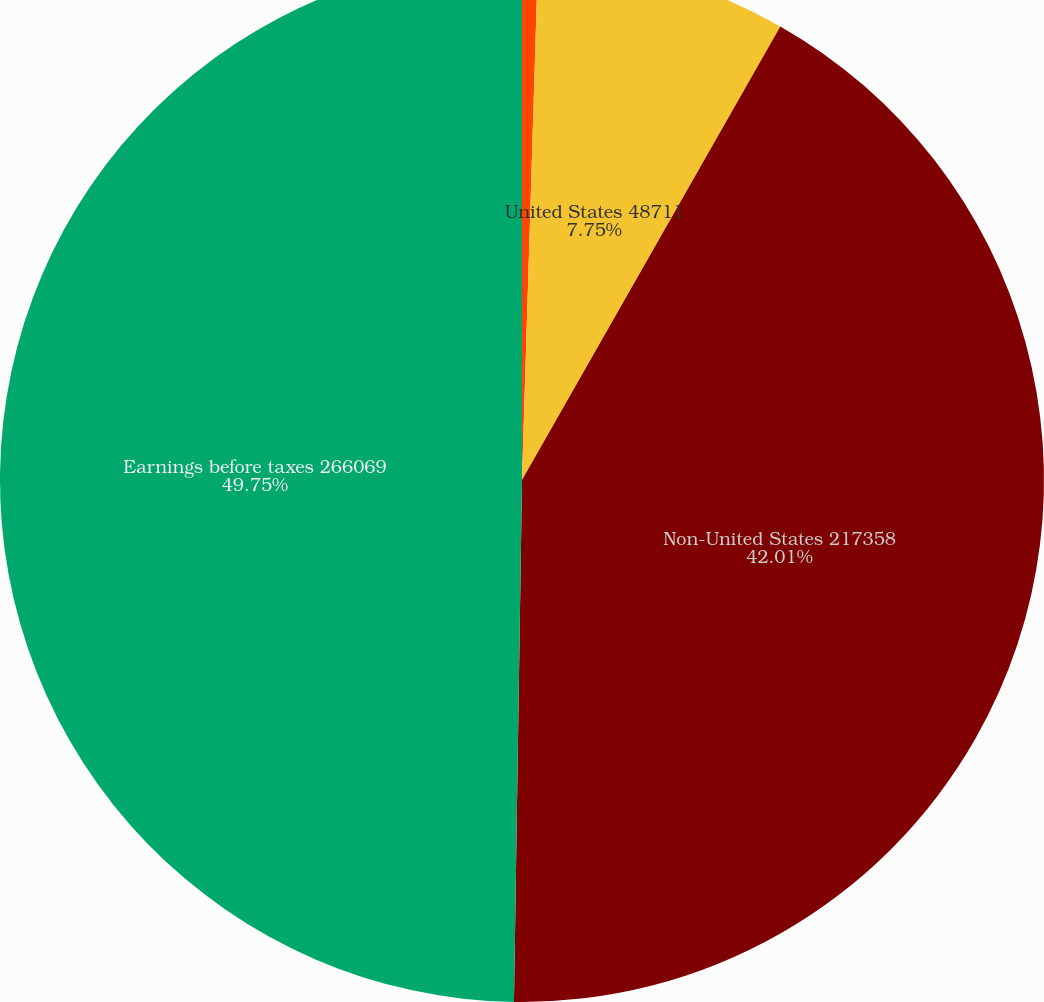Convert chart to OTSL. <chart><loc_0><loc_0><loc_500><loc_500><pie_chart><fcel>2008<fcel>United States 48711<fcel>Non-United States 217358<fcel>Earnings before taxes 266069<nl><fcel>0.49%<fcel>7.75%<fcel>42.01%<fcel>49.76%<nl></chart> 